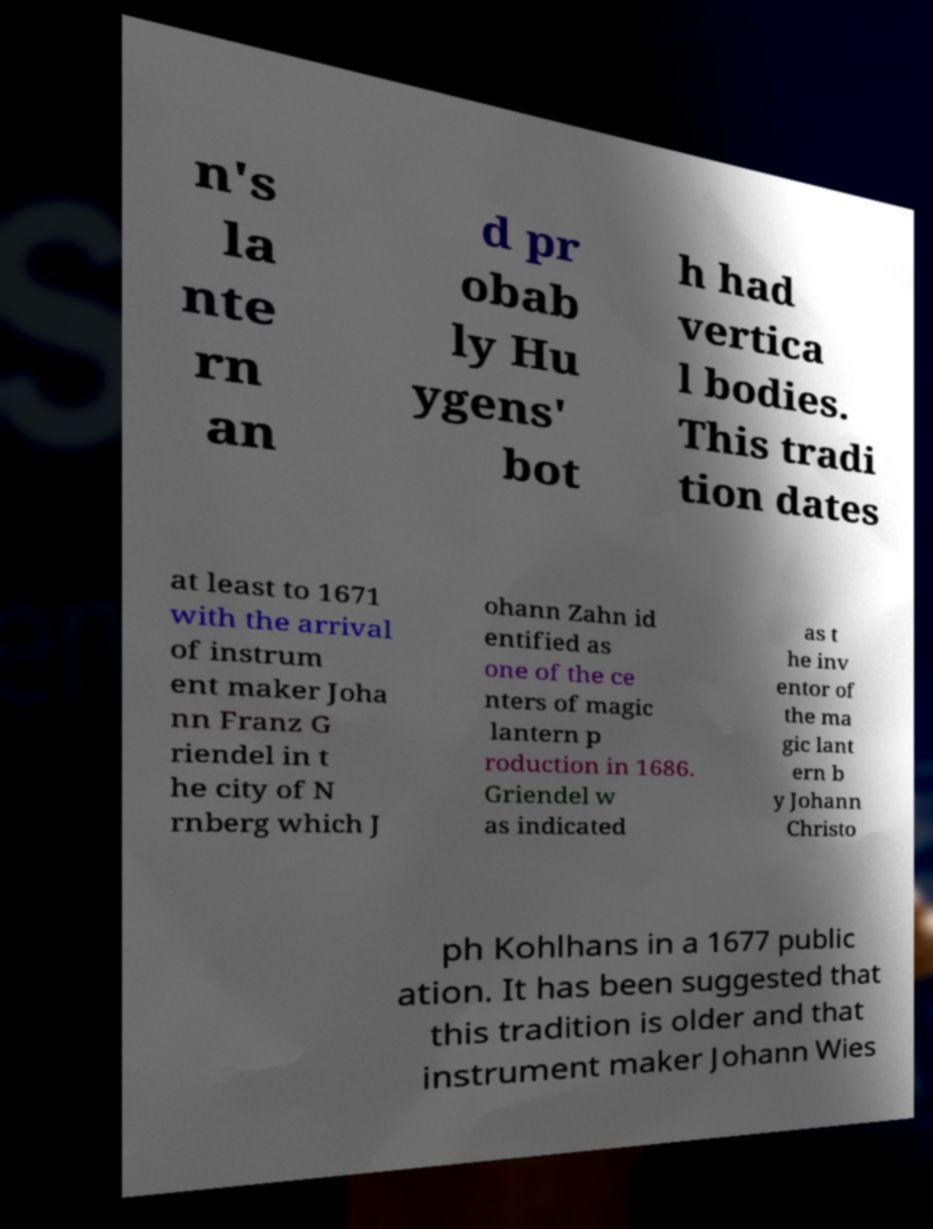What messages or text are displayed in this image? I need them in a readable, typed format. n's la nte rn an d pr obab ly Hu ygens' bot h had vertica l bodies. This tradi tion dates at least to 1671 with the arrival of instrum ent maker Joha nn Franz G riendel in t he city of N rnberg which J ohann Zahn id entified as one of the ce nters of magic lantern p roduction in 1686. Griendel w as indicated as t he inv entor of the ma gic lant ern b y Johann Christo ph Kohlhans in a 1677 public ation. It has been suggested that this tradition is older and that instrument maker Johann Wies 